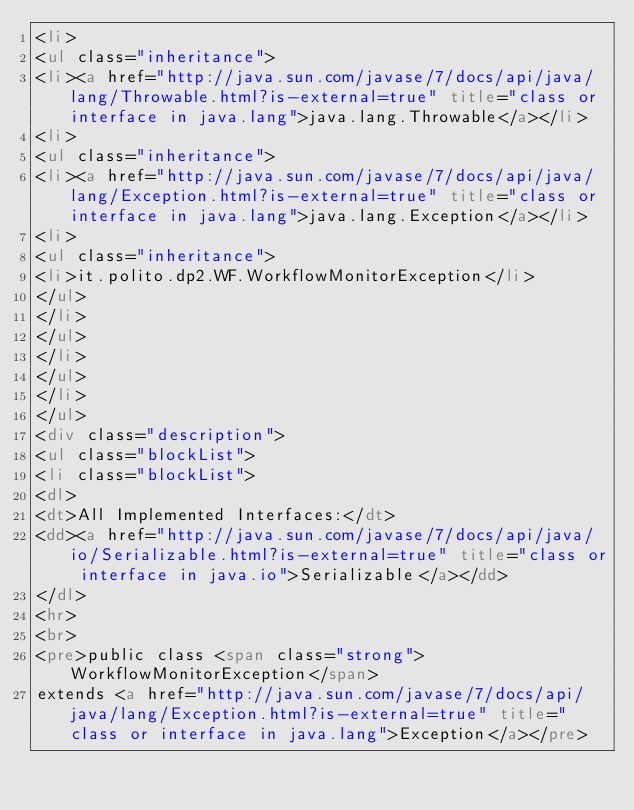<code> <loc_0><loc_0><loc_500><loc_500><_HTML_><li>
<ul class="inheritance">
<li><a href="http://java.sun.com/javase/7/docs/api/java/lang/Throwable.html?is-external=true" title="class or interface in java.lang">java.lang.Throwable</a></li>
<li>
<ul class="inheritance">
<li><a href="http://java.sun.com/javase/7/docs/api/java/lang/Exception.html?is-external=true" title="class or interface in java.lang">java.lang.Exception</a></li>
<li>
<ul class="inheritance">
<li>it.polito.dp2.WF.WorkflowMonitorException</li>
</ul>
</li>
</ul>
</li>
</ul>
</li>
</ul>
<div class="description">
<ul class="blockList">
<li class="blockList">
<dl>
<dt>All Implemented Interfaces:</dt>
<dd><a href="http://java.sun.com/javase/7/docs/api/java/io/Serializable.html?is-external=true" title="class or interface in java.io">Serializable</a></dd>
</dl>
<hr>
<br>
<pre>public class <span class="strong">WorkflowMonitorException</span>
extends <a href="http://java.sun.com/javase/7/docs/api/java/lang/Exception.html?is-external=true" title="class or interface in java.lang">Exception</a></pre></code> 